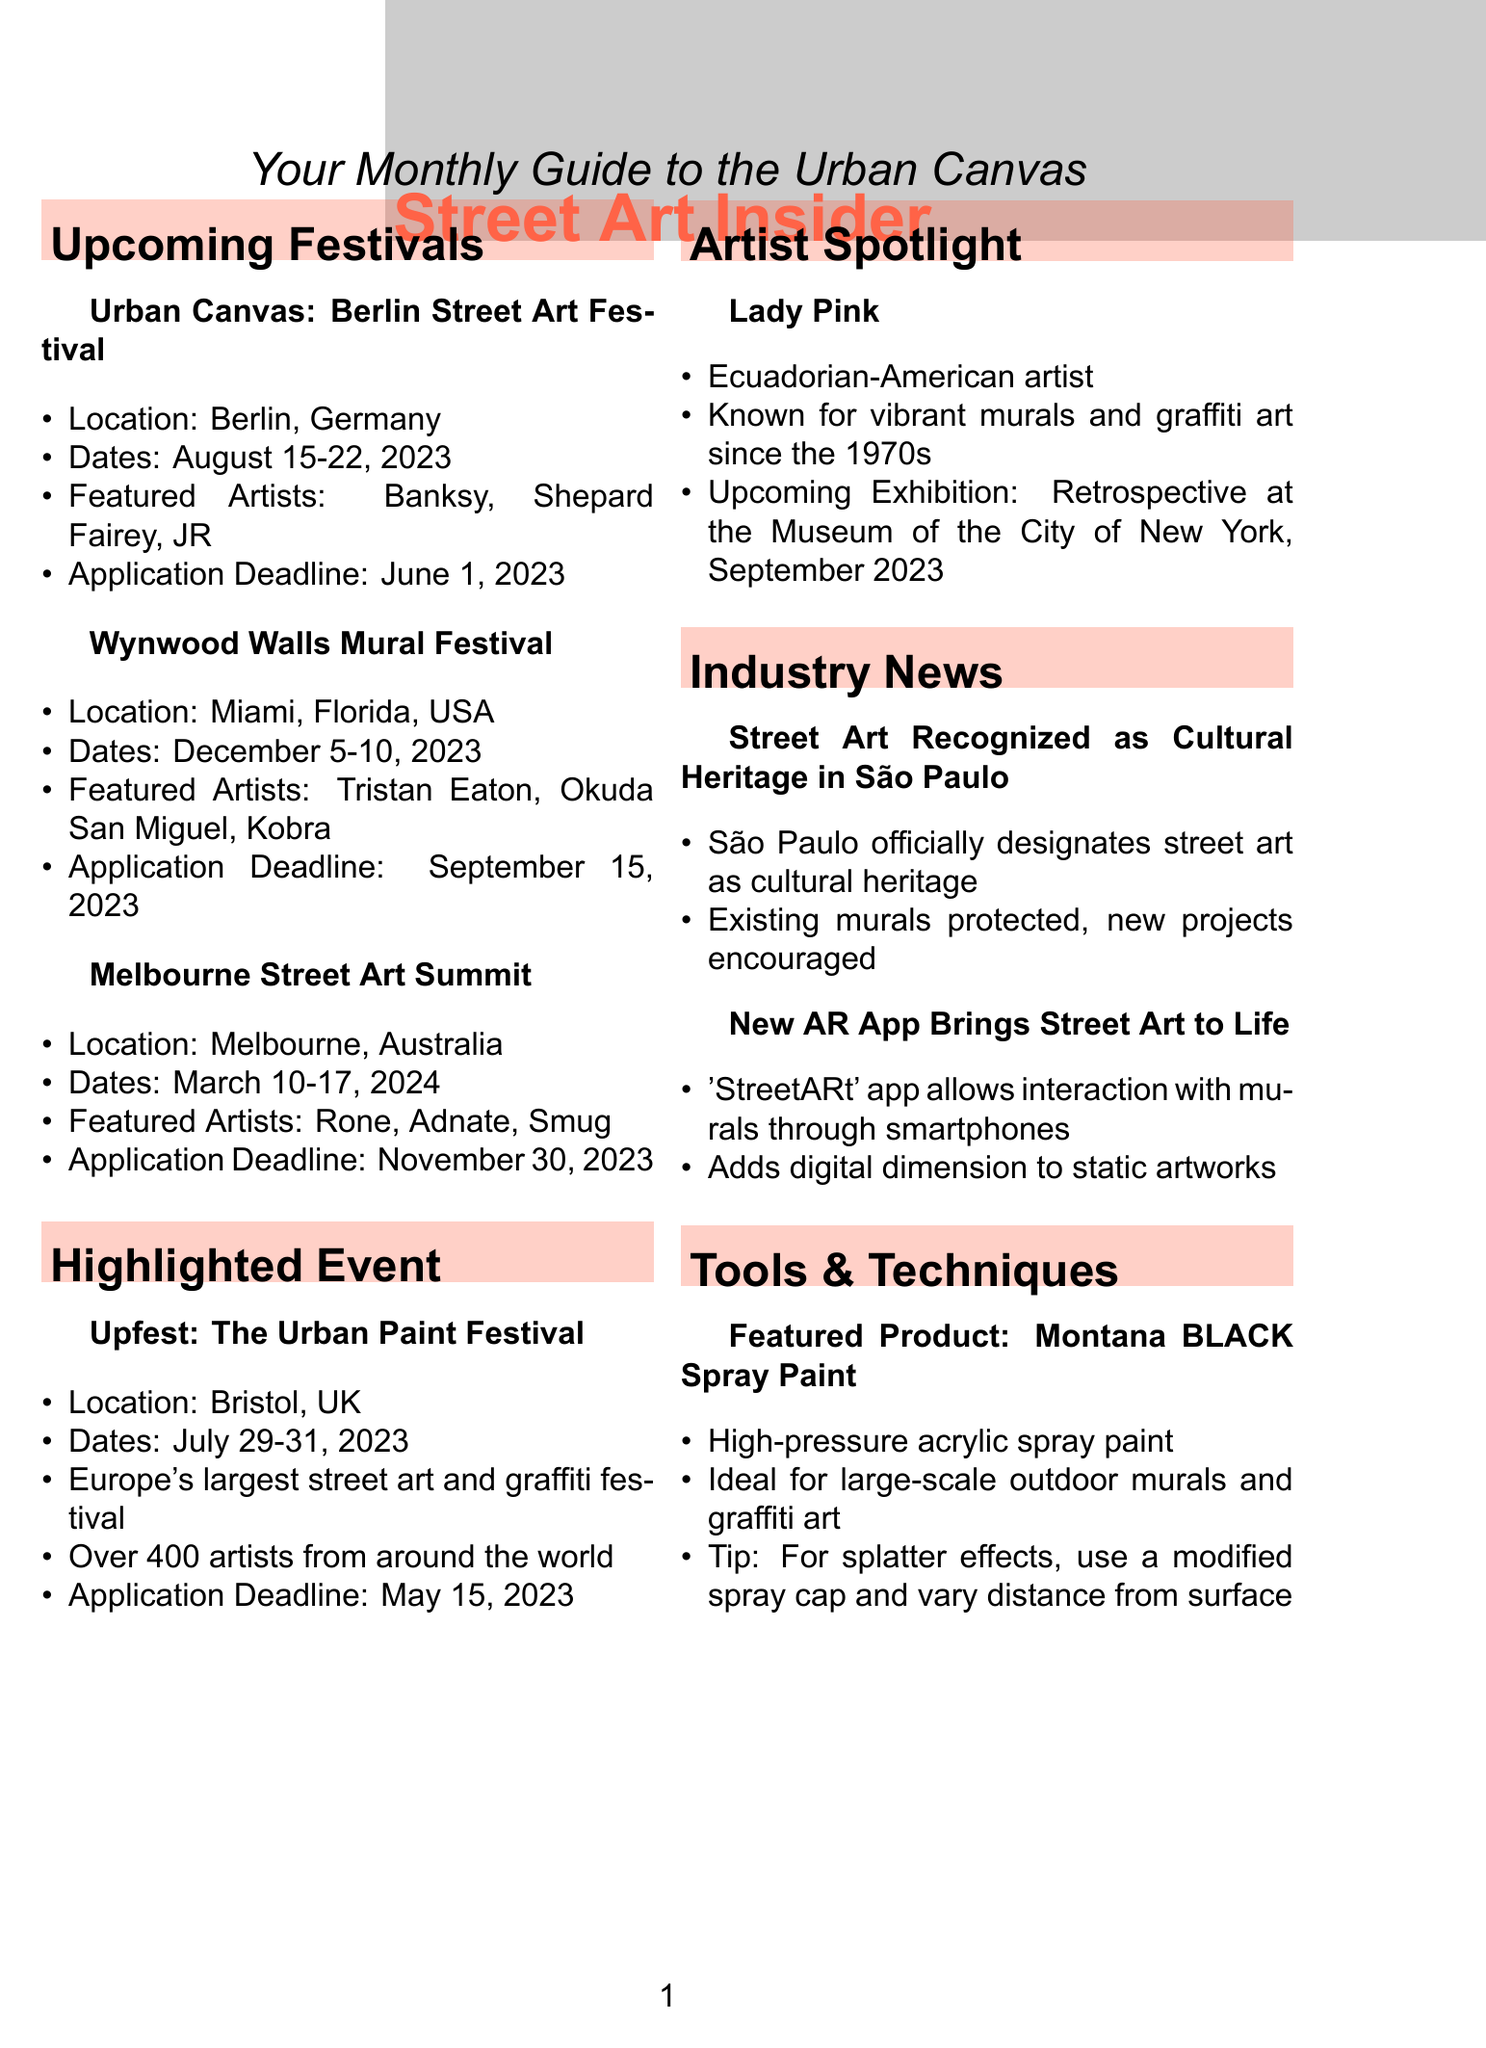What is the location of the Urban Canvas festival? The Urban Canvas festival is held in Berlin, Germany.
Answer: Berlin, Germany Who are the featured artists at the Wynwood Walls Mural Festival? The featured artists at the Wynwood Walls Mural Festival are Tristan Eaton, Okuda San Miguel, and Kobra.
Answer: Tristan Eaton, Okuda San Miguel, Kobra What are the dates for the Melbourne Street Art Summit? The Melbourne Street Art Summit takes place from March 10 to March 17, 2024.
Answer: March 10-17, 2024 What is the application deadline for Upfest? The application deadline for Upfest: The Urban Paint Festival is May 15, 2023.
Answer: May 15, 2023 Which artist is highlighted in the Artist Spotlight section? The highlighted artist in the Artist Spotlight section is Lady Pink.
Answer: Lady Pink What is the title of the upcoming exhibition by Lady Pink? The title of the upcoming exhibition by Lady Pink is a retrospective at the Museum of the City of New York.
Answer: Retrospective at the Museum of the City of New York Which city has officially recognized street art as cultural heritage? The city that has recognized street art as cultural heritage is São Paulo.
Answer: São Paulo What is the featured product in the Tools & Techniques section? The featured product in the Tools & Techniques section is Montana BLACK Spray Paint.
Answer: Montana BLACK Spray Paint What unique feature does the 'StreetARt' app offer? The 'StreetARt' app allows users to interact with murals and graffiti pieces through their smartphones.
Answer: Interaction with murals through smartphones 